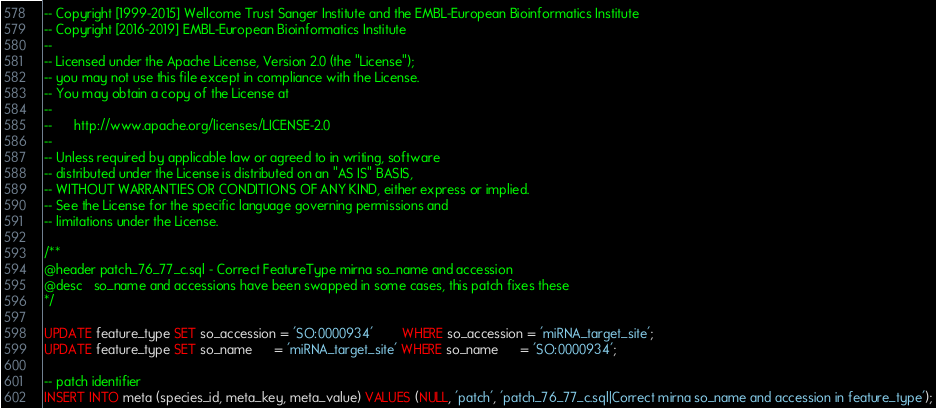<code> <loc_0><loc_0><loc_500><loc_500><_SQL_>-- Copyright [1999-2015] Wellcome Trust Sanger Institute and the EMBL-European Bioinformatics Institute
-- Copyright [2016-2019] EMBL-European Bioinformatics Institute
--
-- Licensed under the Apache License, Version 2.0 (the "License");
-- you may not use this file except in compliance with the License.
-- You may obtain a copy of the License at
--
--      http://www.apache.org/licenses/LICENSE-2.0
--
-- Unless required by applicable law or agreed to in writing, software
-- distributed under the License is distributed on an "AS IS" BASIS,
-- WITHOUT WARRANTIES OR CONDITIONS OF ANY KIND, either express or implied.
-- See the License for the specific language governing permissions and
-- limitations under the License.

/**
@header patch_76_77_c.sql - Correct FeatureType mirna so_name and accession
@desc   so_name and accessions have been swapped in some cases, this patch fixes these
*/

UPDATE feature_type SET so_accession = 'SO:0000934'        WHERE so_accession = 'miRNA_target_site';
UPDATE feature_type SET so_name      = 'miRNA_target_site' WHERE so_name      = 'SO:0000934';

-- patch identifier
INSERT INTO meta (species_id, meta_key, meta_value) VALUES (NULL, 'patch', 'patch_76_77_c.sql|Correct mirna so_name and accession in feature_type');



</code> 